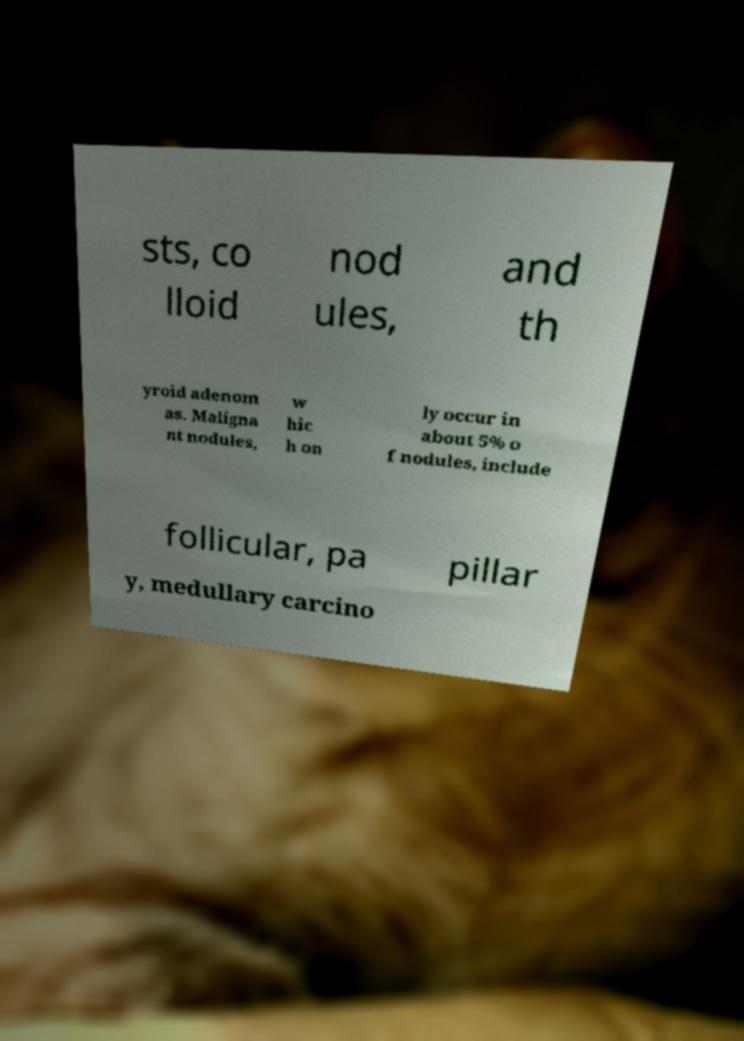Can you accurately transcribe the text from the provided image for me? sts, co lloid nod ules, and th yroid adenom as. Maligna nt nodules, w hic h on ly occur in about 5% o f nodules, include follicular, pa pillar y, medullary carcino 